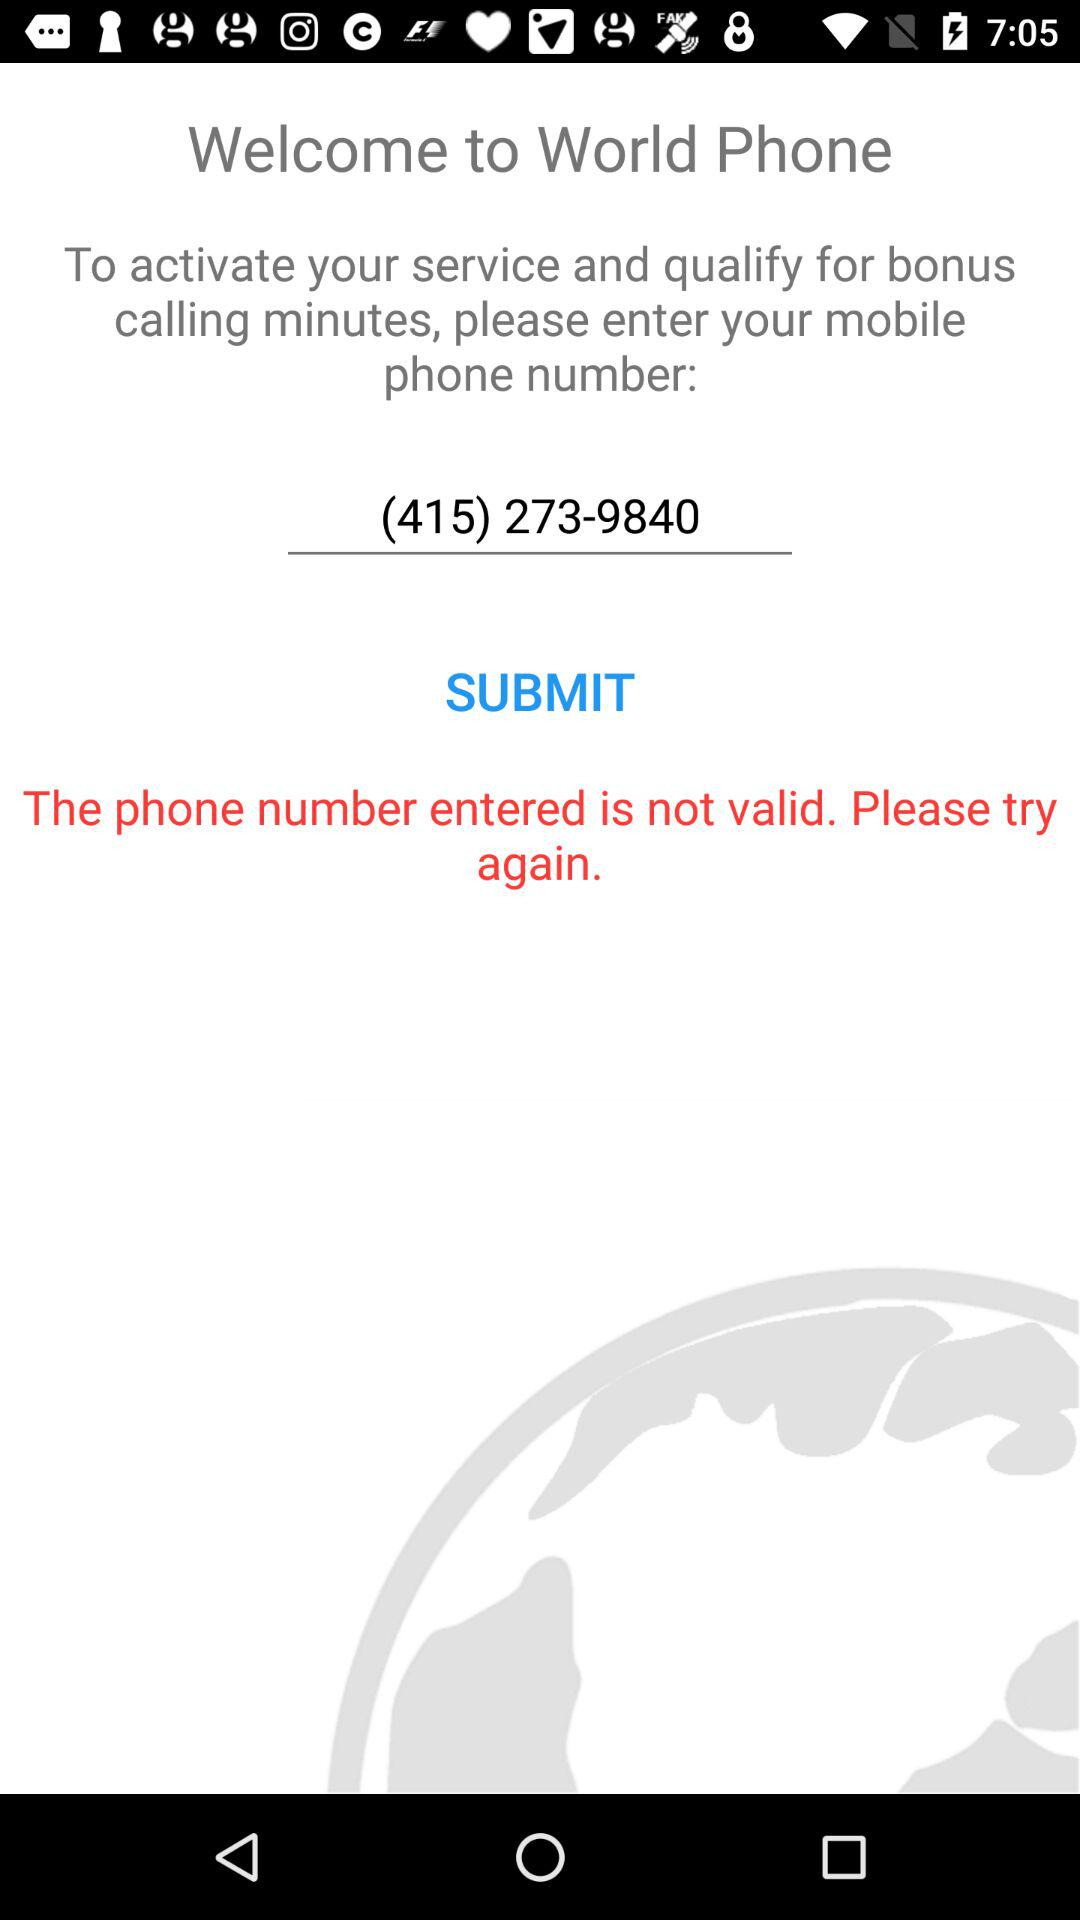What is the phone number? The phone number is (415) 273-9840. 